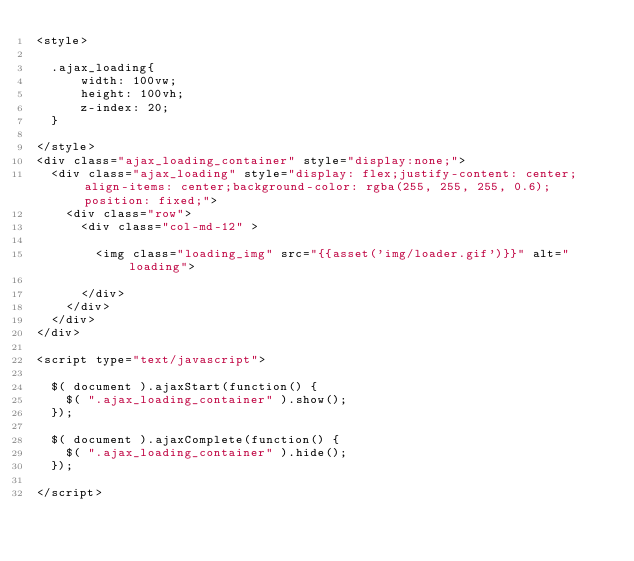Convert code to text. <code><loc_0><loc_0><loc_500><loc_500><_PHP_><style>

  .ajax_loading{
      width: 100vw;
      height: 100vh;
      z-index: 20;
  }

</style>
<div class="ajax_loading_container" style="display:none;">
  <div class="ajax_loading" style="display: flex;justify-content: center;align-items: center;background-color: rgba(255, 255, 255, 0.6);position: fixed;">
    <div class="row">
      <div class="col-md-12" >

        <img class="loading_img" src="{{asset('img/loader.gif')}}" alt="loading">

      </div>
    </div>
  </div>
</div>

<script type="text/javascript">

  $( document ).ajaxStart(function() {
    $( ".ajax_loading_container" ).show();
  });

  $( document ).ajaxComplete(function() {
    $( ".ajax_loading_container" ).hide();
  });

</script>
</code> 